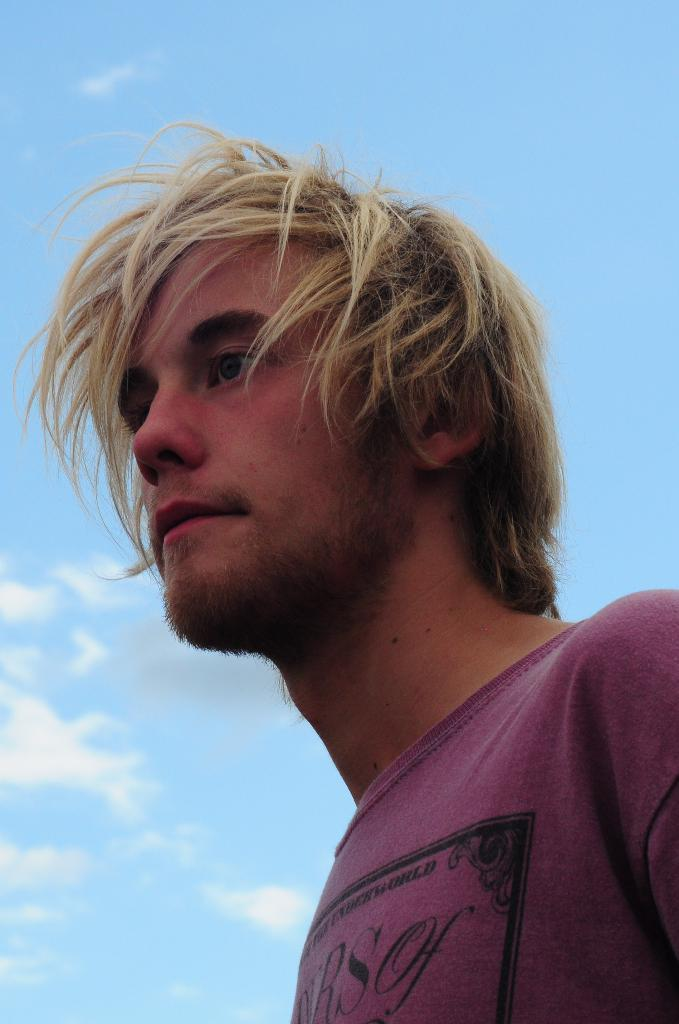Who is present in the image? There is a man in the image. What is visible in the background behind the man? The sky is visible behind the man. How would you describe the sky in the image? The sky appears to be clear. What type of shock can be seen on the man's face in the image? There is no shock visible on the man's face in the image, as the provided facts do not mention any facial expressions or emotions. 